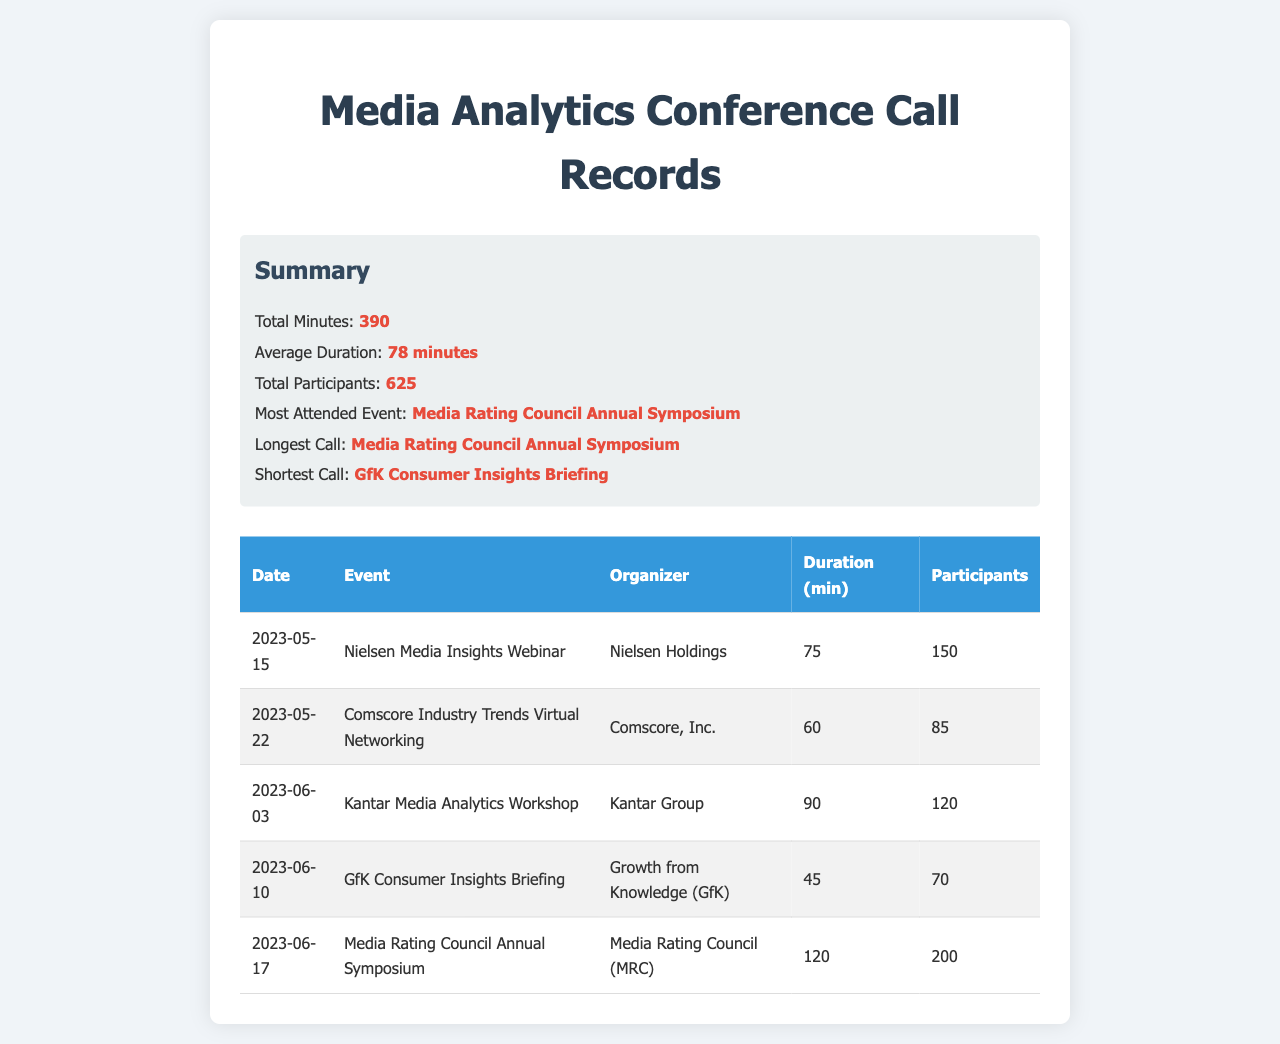What was the total minutes of calls? The total minutes of calls is summarized in the document, which states that there were 390 minutes used in total.
Answer: 390 Which event had the longest call duration? The longest call duration is specified in the summary of the document as the Media Rating Council Annual Symposium.
Answer: Media Rating Council Annual Symposium How many participants attended the Nielsen Media Insights Webinar? The number of participants for the Nielsen Media Insights Webinar is provided in the table as 150 participants.
Answer: 150 What was the duration of the GfK Consumer Insights Briefing? The duration of the GfK Consumer Insights Briefing is noted in the table as 45 minutes.
Answer: 45 Who organized the Kantar Media Analytics Workshop? The organizer of the Kantar Media Analytics Workshop is identified in the table as Kantar Group.
Answer: Kantar Group What is the average duration of the calls? The average duration of calls is calculated and summarized in the document as 78 minutes.
Answer: 78 minutes How many events were held according to the records? The total number of events listed in the table is deduced to be 5, as shown by the number of entries in the table.
Answer: 5 Which event was the most attended? The most attended event is highlighted in the summary as the Media Rating Council Annual Symposium.
Answer: Media Rating Council Annual Symposium 